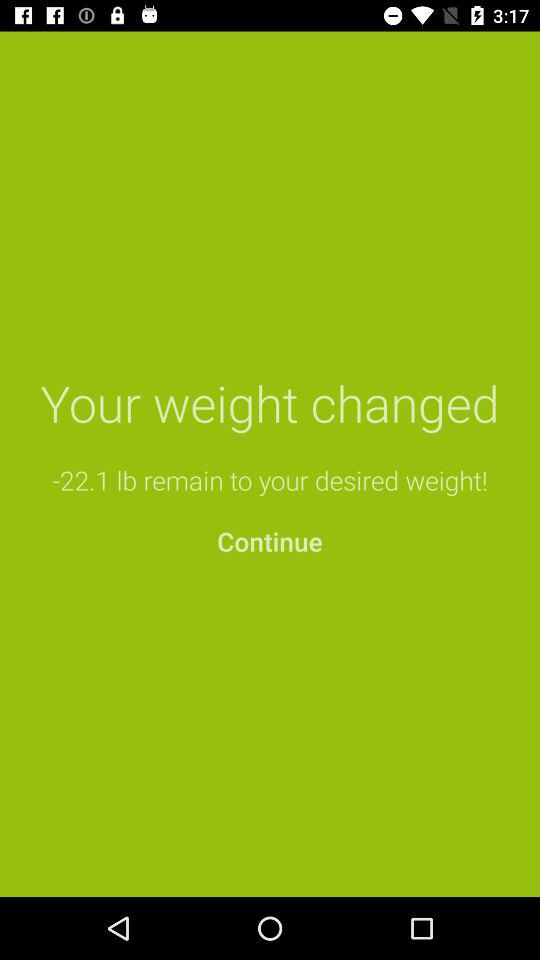How many pounds do I need to lose to reach my desired weight?
Answer the question using a single word or phrase. -22.1 